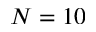Convert formula to latex. <formula><loc_0><loc_0><loc_500><loc_500>N = 1 0</formula> 